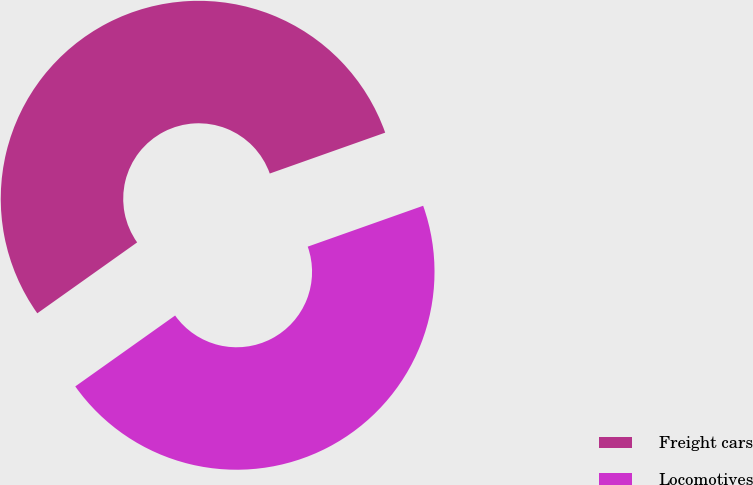Convert chart to OTSL. <chart><loc_0><loc_0><loc_500><loc_500><pie_chart><fcel>Freight cars<fcel>Locomotives<nl><fcel>54.41%<fcel>45.59%<nl></chart> 